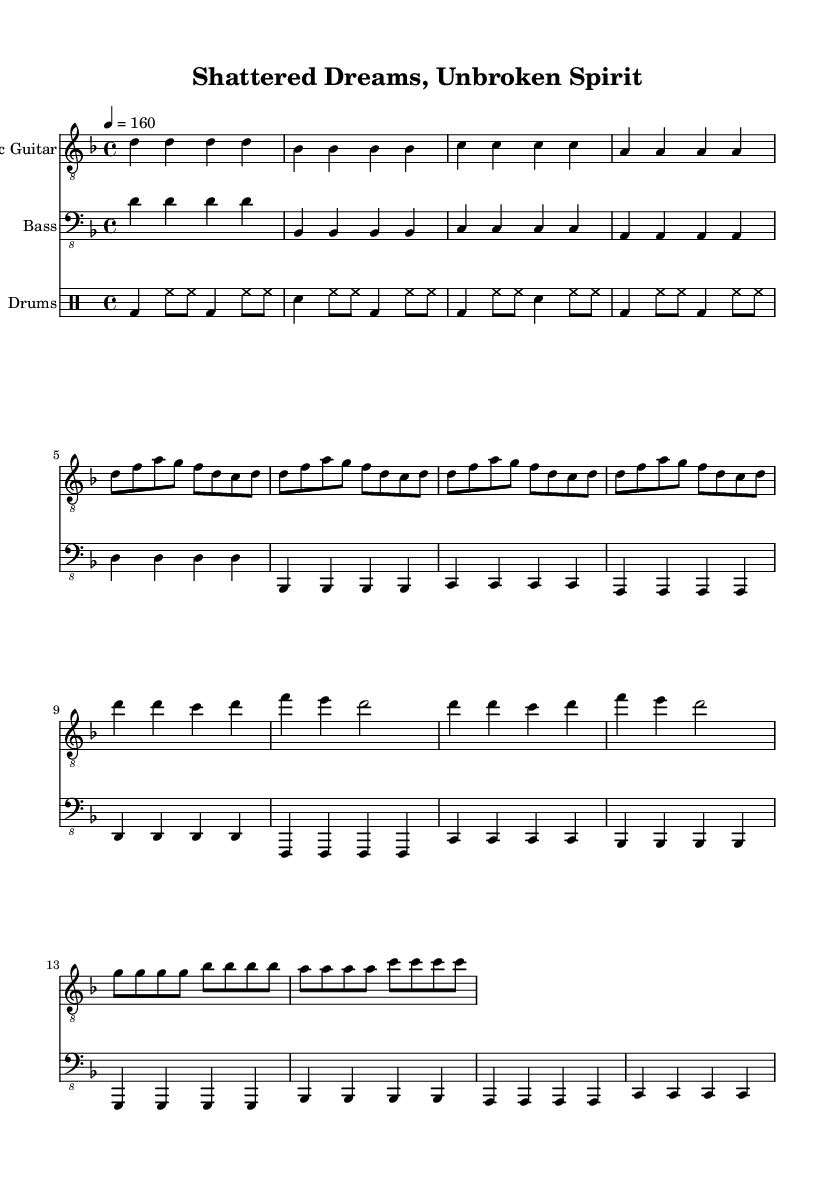What is the key signature of this music? The key signature is indicated by the number of sharps or flats at the beginning of the staff. In this piece, there are no sharps or flats, which means it is in D minor.
Answer: D minor What is the time signature of the piece? The time signature is found at the beginning of the music, and it consists of two numbers that indicate how many beats are in each measure and what note value (like a quarter note) gets one beat. This piece has a time signature of 4 over 4, meaning there are four beats in each measure.
Answer: 4/4 What is the tempo marking of the music? The tempo marking is indicated in beats per minute (BPM). In this piece, it states "4 = 160," which means there are 160 beats per minute, or the quarter note gets the beat.
Answer: 160 What is the primary theme of the lyrics likely portrayed in the music? Given the title "Shattered Dreams, Unbroken Spirit" and the aggressive nature of metal, the primary theme is likely about overcoming challenges and personal struggles. This reflects typical lyrical themes in aggressive metal music.
Answer: Overcoming adversity Which section of the music has the most intensity based on the arrangement? In metal compositions, intensity often peaks during the chorus, where themes are restated with more emphasis and volume. In this piece, the chorus is characterized by a pronounced and powerful structure, making it the most intense section.
Answer: Chorus What instrument plays the main melodic line in the music? The main melodic line is often played by the electric guitar, as indicated in the score. The electric guitar part prominently features melodic phrases that drive the music forward.
Answer: Electric Guitar 